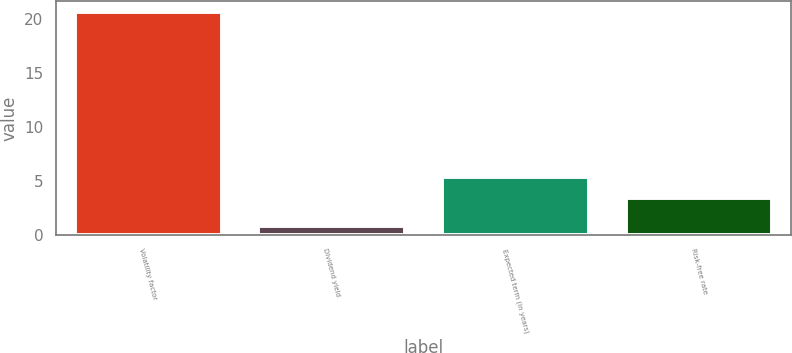Convert chart. <chart><loc_0><loc_0><loc_500><loc_500><bar_chart><fcel>Volatility factor<fcel>Dividend yield<fcel>Expected term (in years)<fcel>Risk-free rate<nl><fcel>20.6<fcel>0.8<fcel>5.38<fcel>3.4<nl></chart> 